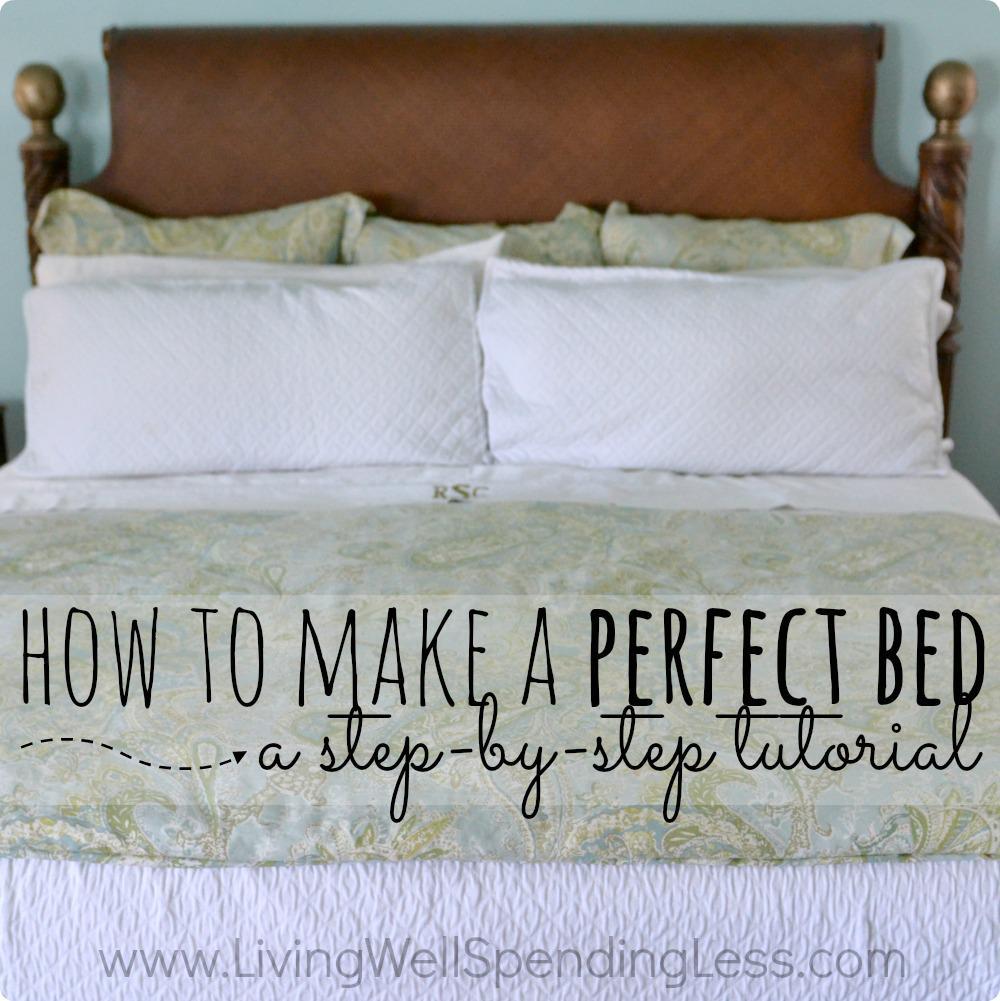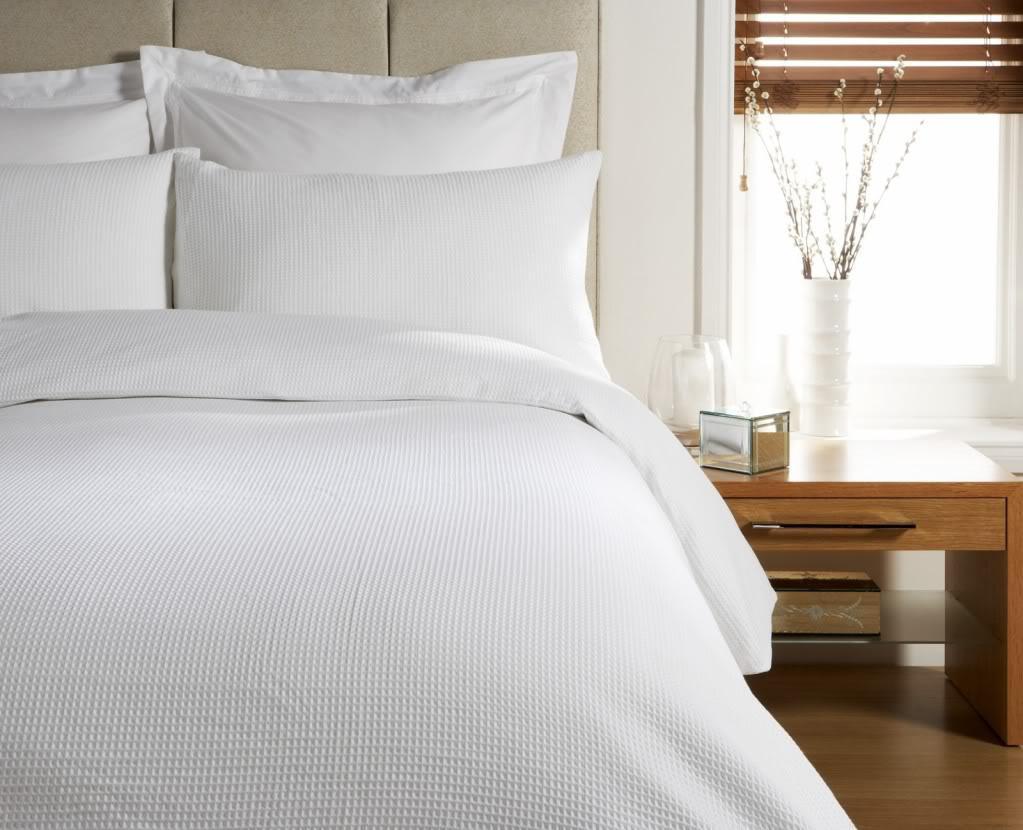The first image is the image on the left, the second image is the image on the right. Assess this claim about the two images: "There are lamps on each side of a bed". Correct or not? Answer yes or no. No. 